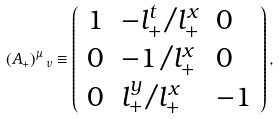<formula> <loc_0><loc_0><loc_500><loc_500>( A _ { + } ) ^ { \mu } \, _ { \nu } \equiv \left ( \begin{array} { l l l } { 1 } & { { - l _ { + } ^ { t } / l _ { + } ^ { x } } } & { 0 } \\ { 0 } & { { - 1 / l _ { + } ^ { x } } } & { 0 } \\ { 0 } & { { l _ { + } ^ { y } / l _ { + } ^ { x } } } & { - 1 } \end{array} \right ) ,</formula> 